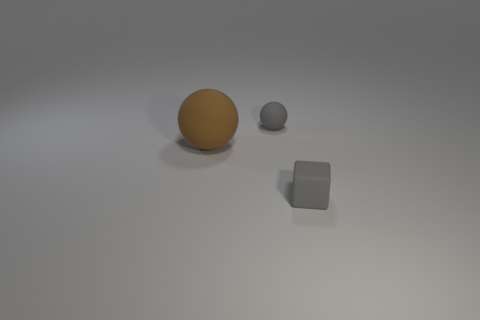What textures are visible on the objects? The three objects display distinct textures; the sphere on the left has a reflective, smooth surface, the smaller sphere appears to have a matte finish, and the cube also has a matte texture but with a visible roughness to its sides. Which object appears to be in the foreground? The object that appears to be in the foreground due to its size and placement is the larger, reflective sphere. 